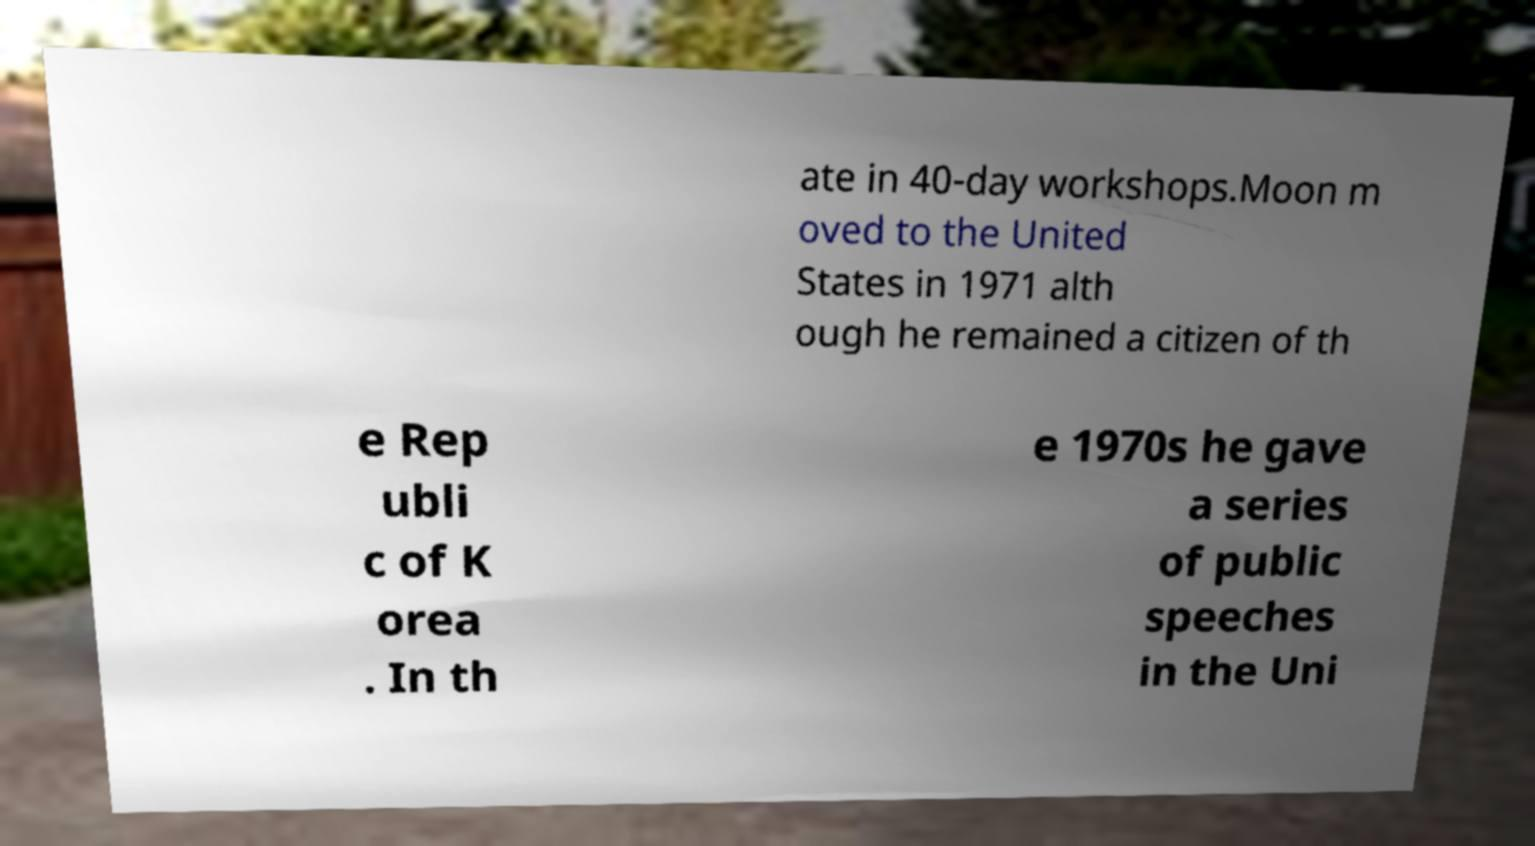Can you read and provide the text displayed in the image?This photo seems to have some interesting text. Can you extract and type it out for me? ate in 40-day workshops.Moon m oved to the United States in 1971 alth ough he remained a citizen of th e Rep ubli c of K orea . In th e 1970s he gave a series of public speeches in the Uni 